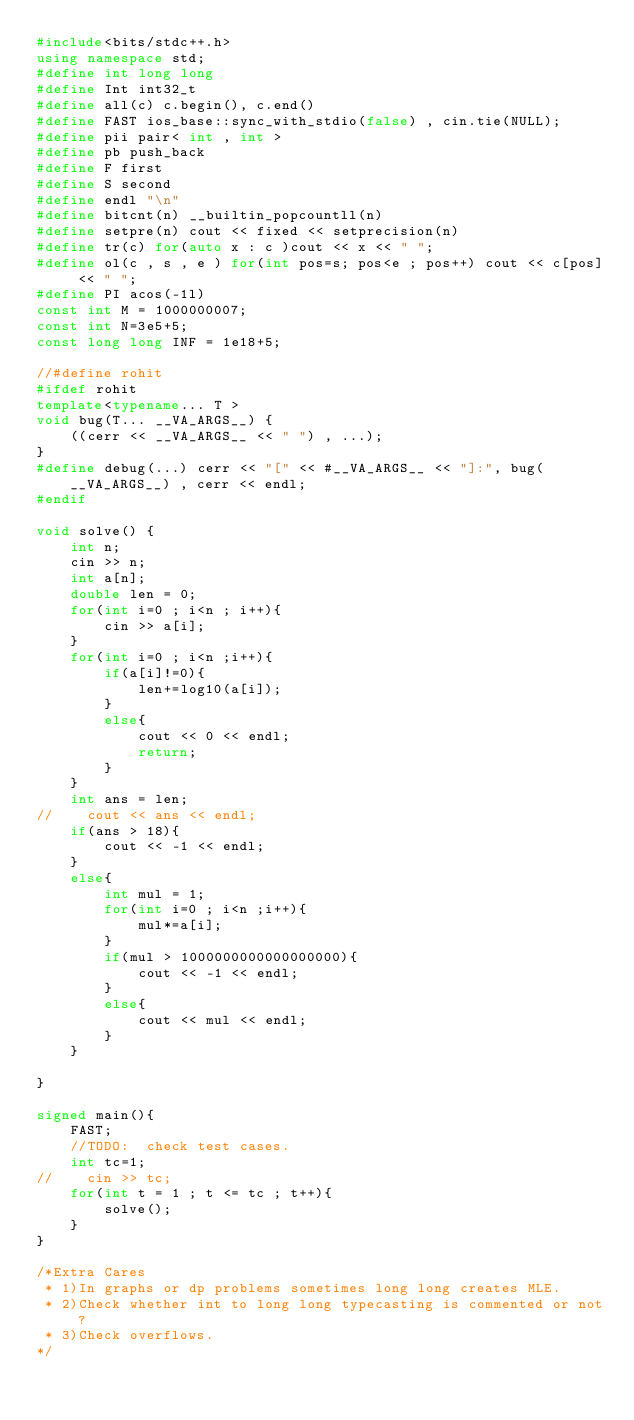Convert code to text. <code><loc_0><loc_0><loc_500><loc_500><_C++_>#include<bits/stdc++.h>
using namespace std;
#define int long long
#define Int int32_t
#define all(c) c.begin(), c.end()
#define FAST ios_base::sync_with_stdio(false) , cin.tie(NULL);
#define pii pair< int , int >
#define pb push_back
#define F first
#define S second
#define endl "\n"
#define bitcnt(n) __builtin_popcountll(n)
#define setpre(n) cout << fixed << setprecision(n)
#define tr(c) for(auto x : c )cout << x << " ";
#define ol(c , s , e ) for(int pos=s; pos<e ; pos++) cout << c[pos] << " ";
#define PI acos(-1l)
const int M = 1000000007;
const int N=3e5+5;
const long long INF = 1e18+5;

//#define rohit
#ifdef rohit
template<typename... T >
void bug(T... __VA_ARGS__) {
    ((cerr << __VA_ARGS__ << " ") , ...);
}
#define debug(...) cerr << "[" << #__VA_ARGS__ << "]:", bug(__VA_ARGS__) , cerr << endl;
#endif

void solve() {
    int n;
    cin >> n;
    int a[n];
    double len = 0;
    for(int i=0 ; i<n ; i++){
        cin >> a[i];
    }
    for(int i=0 ; i<n ;i++){
        if(a[i]!=0){
            len+=log10(a[i]);
        }
        else{
            cout << 0 << endl;
            return;
        }
    }
    int ans = len;
//    cout << ans << endl;
    if(ans > 18){
        cout << -1 << endl;
    }
    else{
        int mul = 1;
        for(int i=0 ; i<n ;i++){
            mul*=a[i];
        }
        if(mul > 1000000000000000000){
            cout << -1 << endl;
        }
        else{
            cout << mul << endl;
        }
    }

}

signed main(){
    FAST;
    //TODO:  check test cases.
    int tc=1;
//    cin >> tc;
    for(int t = 1 ; t <= tc ; t++){
        solve();
    }
}

/*Extra Cares
 * 1)In graphs or dp problems sometimes long long creates MLE.
 * 2)Check whether int to long long typecasting is commented or not?
 * 3)Check overflows.
*/</code> 